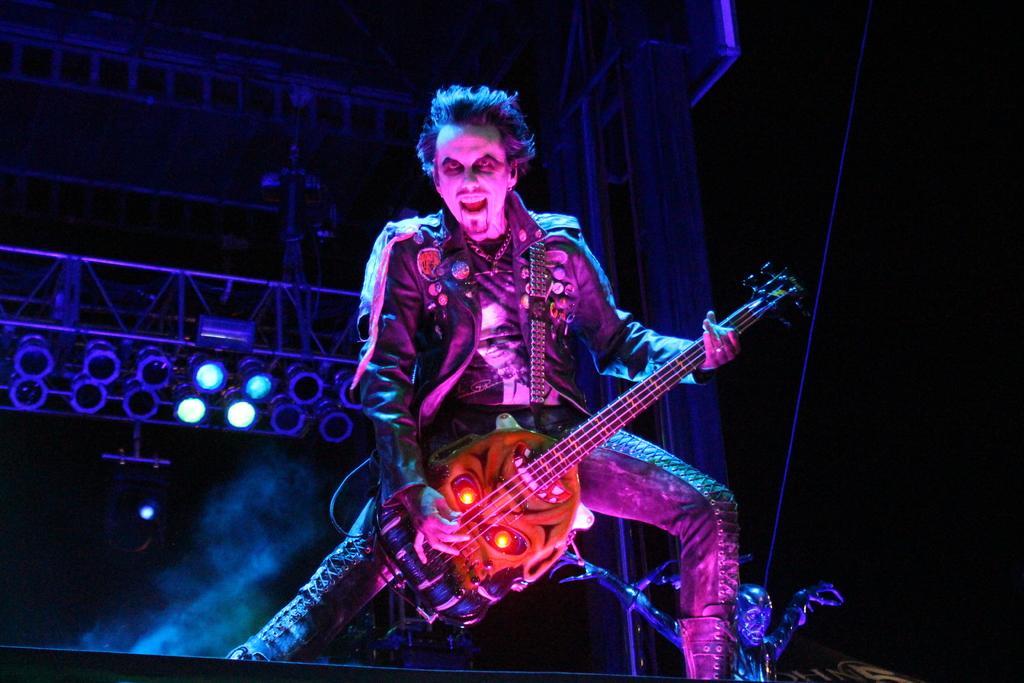Describe this image in one or two sentences. In this image in front there is a person holding the guitar. Behind him there is a depiction of a person. In the background of the image there are lights, metal rods. 